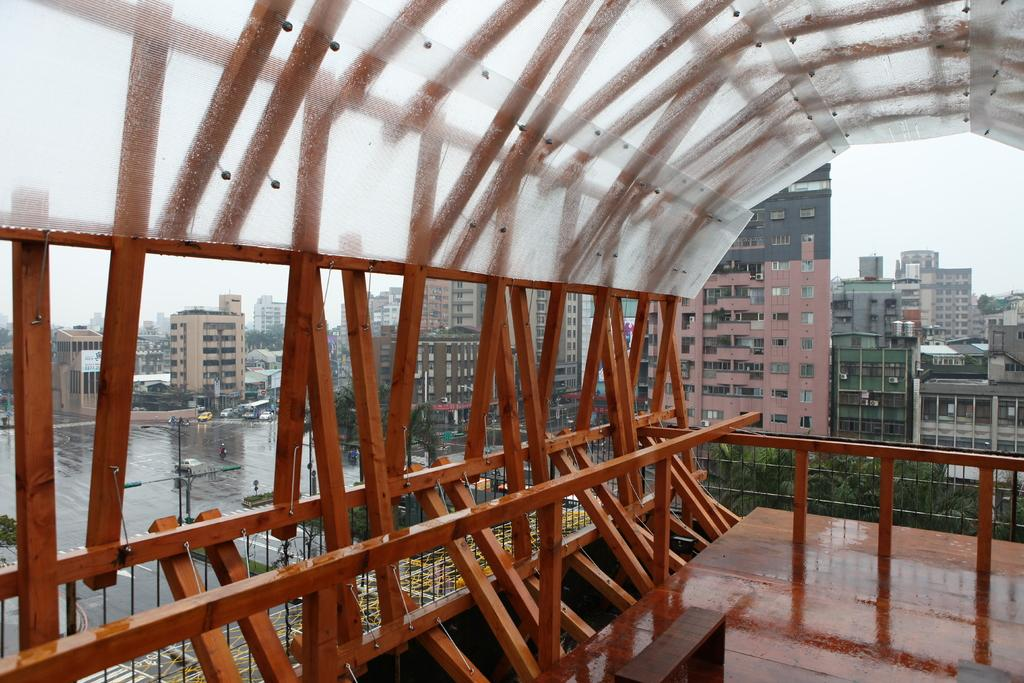What type of structure can be seen in the image? There is a bridge in the image. What else can be seen in the image besides the bridge? There are buildings, windows, light poles, trees, and the sky visible in the image. Can you describe the weather in the image? It appears to be raining in the image. What type of unit is being measured by the bat in the image? There is no bat or unit present in the image. What is the moon's position in the image? The moon is not visible in the image. 